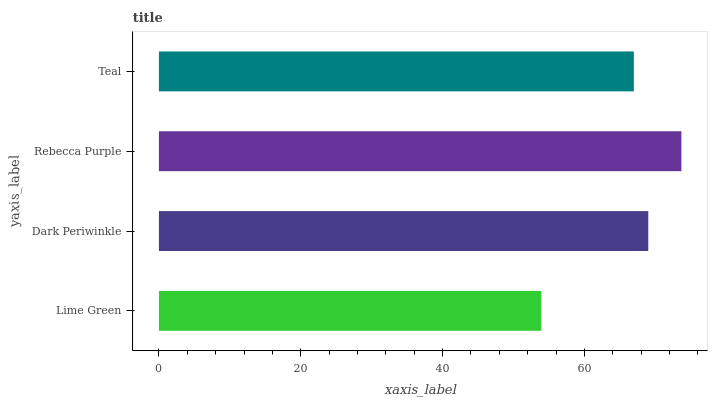Is Lime Green the minimum?
Answer yes or no. Yes. Is Rebecca Purple the maximum?
Answer yes or no. Yes. Is Dark Periwinkle the minimum?
Answer yes or no. No. Is Dark Periwinkle the maximum?
Answer yes or no. No. Is Dark Periwinkle greater than Lime Green?
Answer yes or no. Yes. Is Lime Green less than Dark Periwinkle?
Answer yes or no. Yes. Is Lime Green greater than Dark Periwinkle?
Answer yes or no. No. Is Dark Periwinkle less than Lime Green?
Answer yes or no. No. Is Dark Periwinkle the high median?
Answer yes or no. Yes. Is Teal the low median?
Answer yes or no. Yes. Is Teal the high median?
Answer yes or no. No. Is Lime Green the low median?
Answer yes or no. No. 